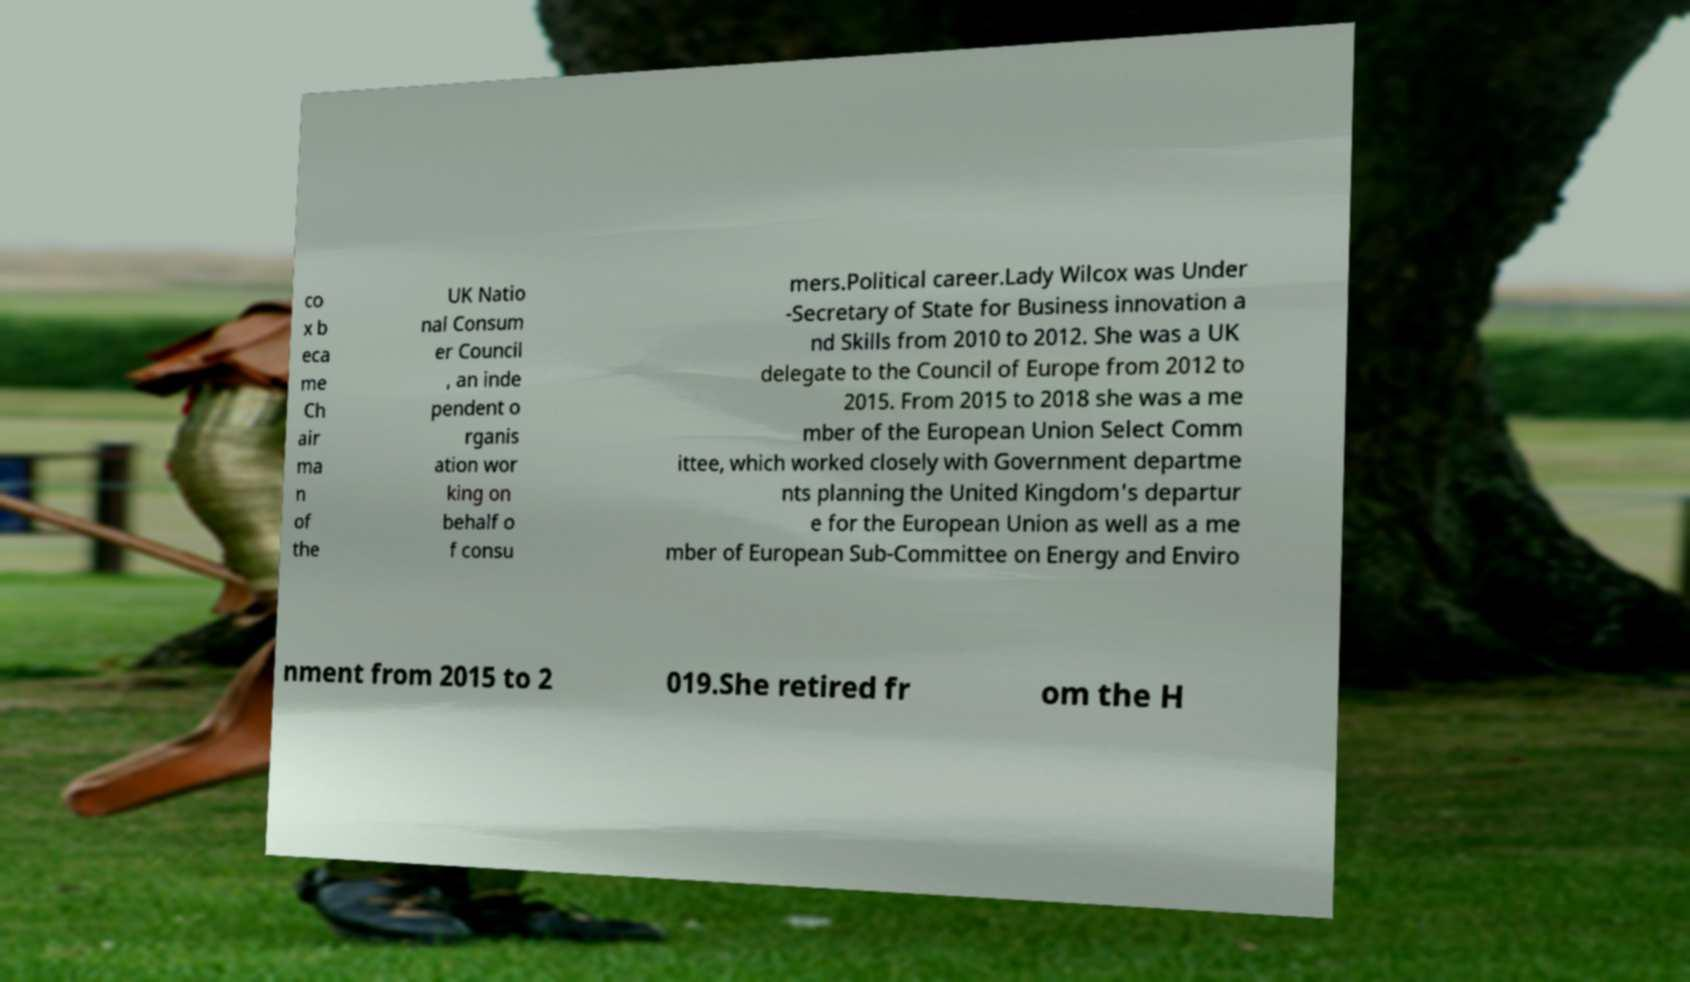Could you extract and type out the text from this image? co x b eca me Ch air ma n of the UK Natio nal Consum er Council , an inde pendent o rganis ation wor king on behalf o f consu mers.Political career.Lady Wilcox was Under -Secretary of State for Business innovation a nd Skills from 2010 to 2012. She was a UK delegate to the Council of Europe from 2012 to 2015. From 2015 to 2018 she was a me mber of the European Union Select Comm ittee, which worked closely with Government departme nts planning the United Kingdom's departur e for the European Union as well as a me mber of European Sub-Committee on Energy and Enviro nment from 2015 to 2 019.She retired fr om the H 